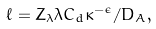<formula> <loc_0><loc_0><loc_500><loc_500>\ell = Z _ { \lambda } \lambda C _ { d } \kappa ^ { - \epsilon } / D _ { A } ,</formula> 